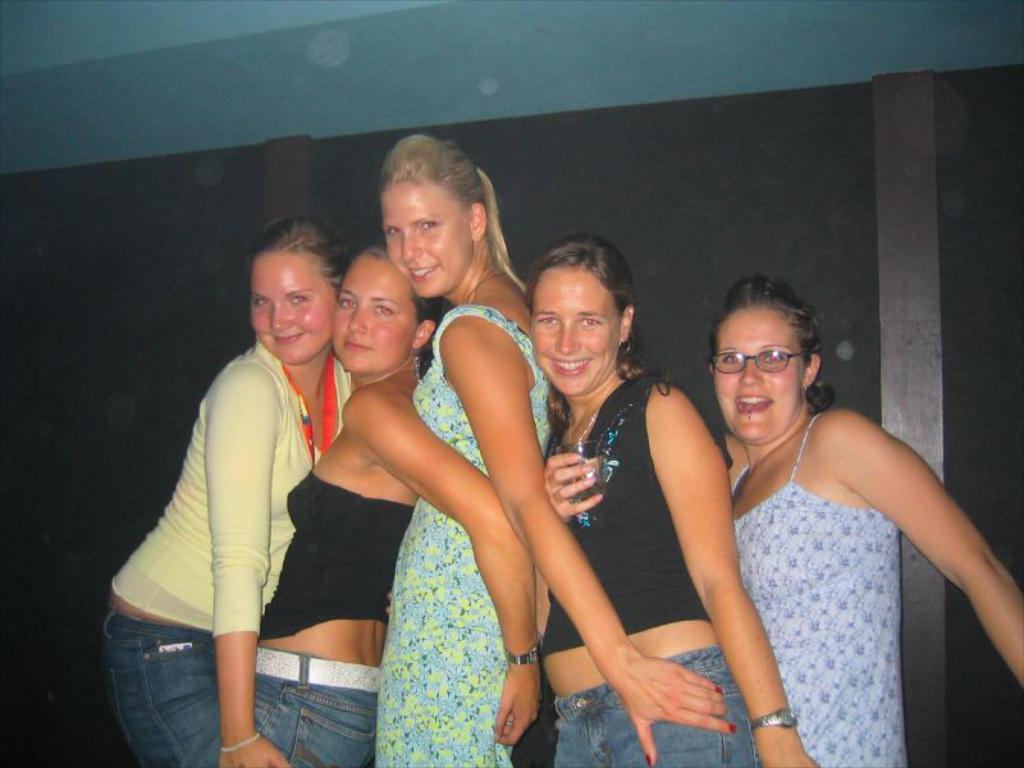Describe this image in one or two sentences. In this image there are a few people standing with a smile on their face. In the background there is a wall. 